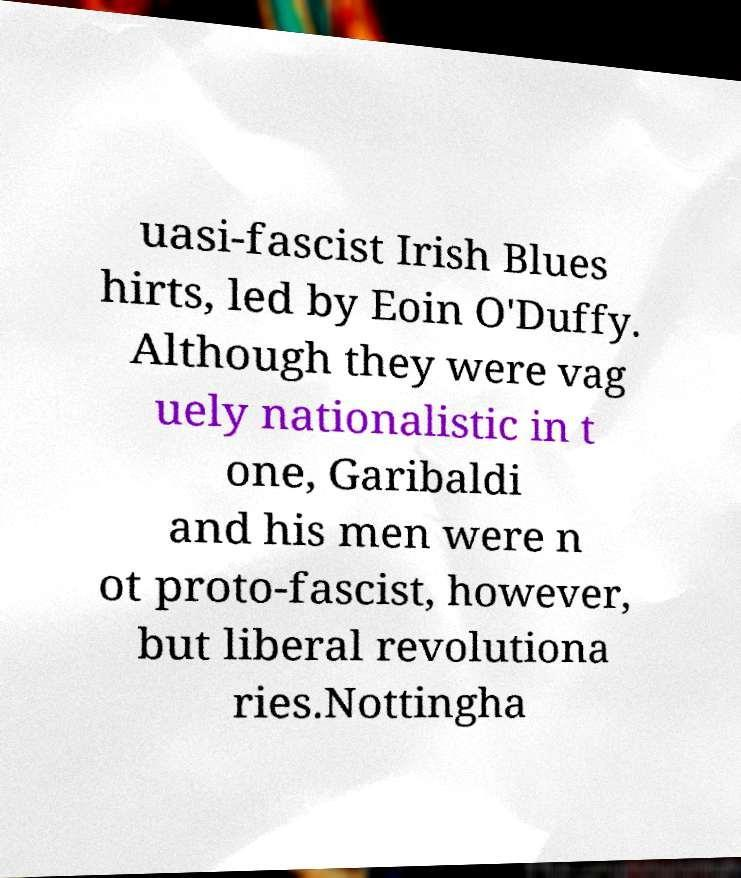Please identify and transcribe the text found in this image. uasi-fascist Irish Blues hirts, led by Eoin O'Duffy. Although they were vag uely nationalistic in t one, Garibaldi and his men were n ot proto-fascist, however, but liberal revolutiona ries.Nottingha 